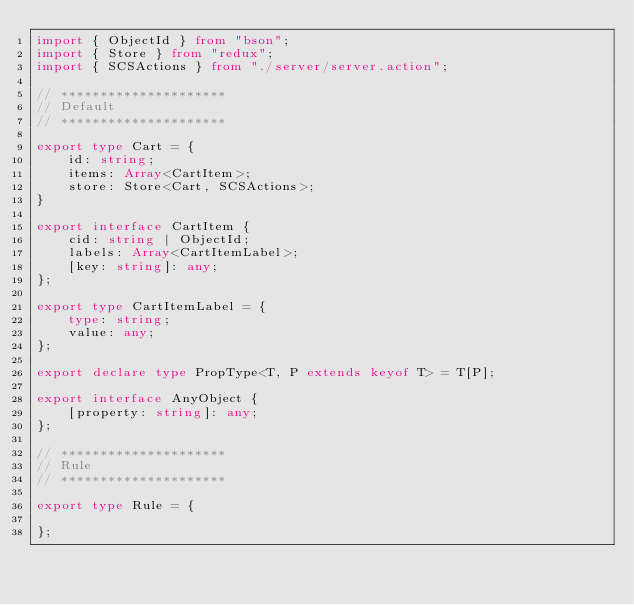Convert code to text. <code><loc_0><loc_0><loc_500><loc_500><_TypeScript_>import { ObjectId } from "bson";
import { Store } from "redux";
import { SCSActions } from "./server/server.action";

// *********************
// Default
// *********************

export type Cart = {
    id: string;
    items: Array<CartItem>;
    store: Store<Cart, SCSActions>;
}

export interface CartItem {
    cid: string | ObjectId;
    labels: Array<CartItemLabel>;
    [key: string]: any;
};

export type CartItemLabel = {
    type: string;
    value: any;
};

export declare type PropType<T, P extends keyof T> = T[P];

export interface AnyObject {
    [property: string]: any;
};

// *********************
// Rule
// *********************

export type Rule = {
    
};
</code> 